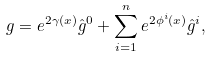<formula> <loc_0><loc_0><loc_500><loc_500>g = e ^ { 2 { \gamma } ( x ) } \hat { g } ^ { 0 } + \sum _ { i = 1 } ^ { n } e ^ { 2 \phi ^ { i } ( x ) } \hat { g } ^ { i } ,</formula> 